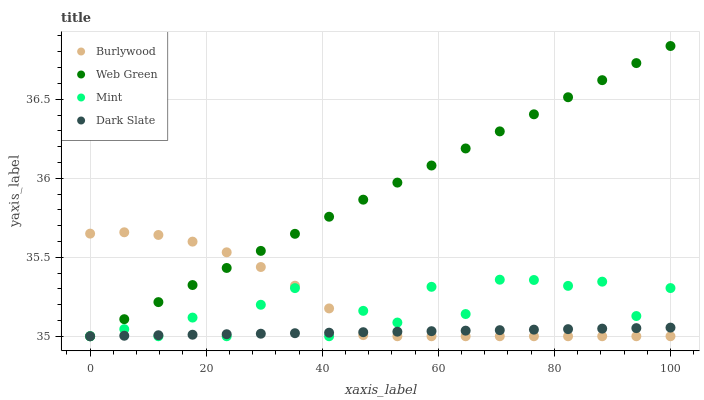Does Dark Slate have the minimum area under the curve?
Answer yes or no. Yes. Does Web Green have the maximum area under the curve?
Answer yes or no. Yes. Does Mint have the minimum area under the curve?
Answer yes or no. No. Does Mint have the maximum area under the curve?
Answer yes or no. No. Is Dark Slate the smoothest?
Answer yes or no. Yes. Is Mint the roughest?
Answer yes or no. Yes. Is Mint the smoothest?
Answer yes or no. No. Is Dark Slate the roughest?
Answer yes or no. No. Does Burlywood have the lowest value?
Answer yes or no. Yes. Does Web Green have the highest value?
Answer yes or no. Yes. Does Mint have the highest value?
Answer yes or no. No. Does Dark Slate intersect Mint?
Answer yes or no. Yes. Is Dark Slate less than Mint?
Answer yes or no. No. Is Dark Slate greater than Mint?
Answer yes or no. No. 